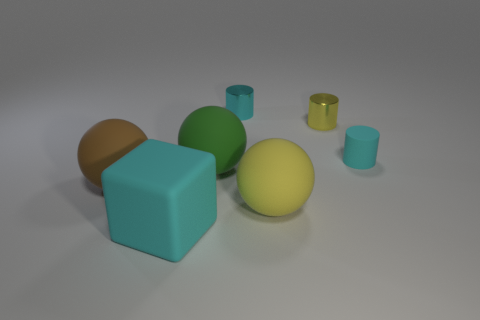Subtract all tiny metallic cylinders. How many cylinders are left? 1 Subtract 1 balls. How many balls are left? 2 Add 1 large green spheres. How many objects exist? 8 Subtract all balls. How many objects are left? 4 Subtract 1 green spheres. How many objects are left? 6 Subtract all big purple matte objects. Subtract all yellow rubber balls. How many objects are left? 6 Add 3 big objects. How many big objects are left? 7 Add 4 large cubes. How many large cubes exist? 5 